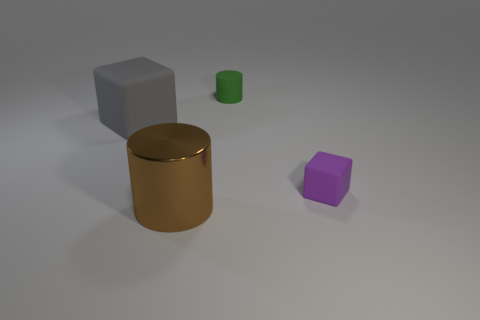Are there any other things that have the same material as the big cylinder?
Offer a very short reply. No. What is the material of the block that is the same size as the green cylinder?
Make the answer very short. Rubber. Do the green cylinder and the big block have the same material?
Give a very brief answer. Yes. What is the color of the object that is in front of the large rubber object and behind the big shiny cylinder?
Keep it short and to the point. Purple. There is a big object left of the brown metal cylinder; is its color the same as the shiny cylinder?
Give a very brief answer. No. There is another thing that is the same size as the green thing; what shape is it?
Your response must be concise. Cube. How many other objects are there of the same color as the large cylinder?
Your answer should be compact. 0. What number of other objects are there of the same material as the green cylinder?
Ensure brevity in your answer.  2. Do the gray rubber block and the matte object that is right of the rubber cylinder have the same size?
Offer a very short reply. No. What is the color of the big metal cylinder?
Provide a short and direct response. Brown. 